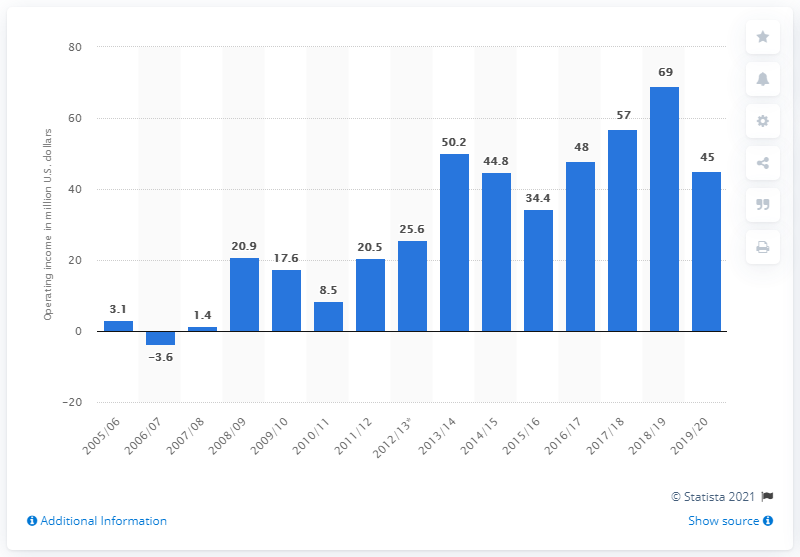Specify some key components in this picture. The operating income of the Chicago Blackhawks for the 2019/20 season was approximately $45 million. 